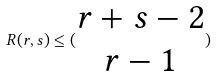Convert formula to latex. <formula><loc_0><loc_0><loc_500><loc_500>R ( r , s ) \leq ( \begin{matrix} r + s - 2 \\ r - 1 \end{matrix} )</formula> 